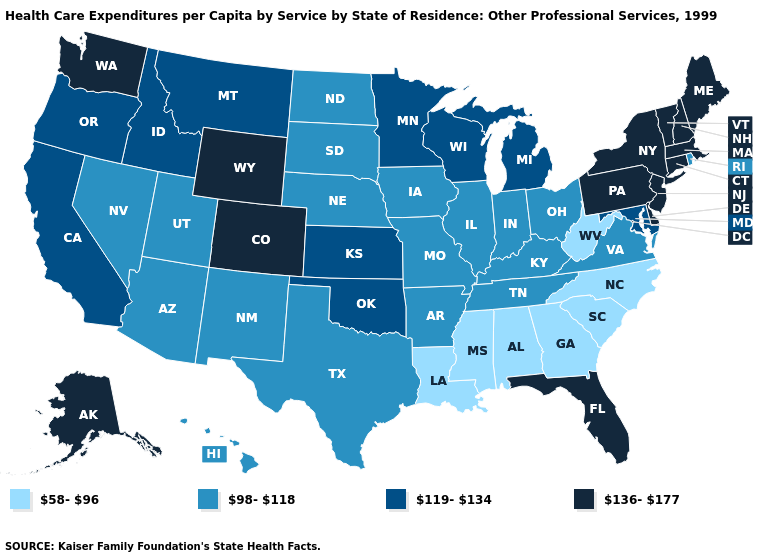Among the states that border Nevada , does Utah have the lowest value?
Short answer required. Yes. Does the map have missing data?
Give a very brief answer. No. Among the states that border Mississippi , does Arkansas have the highest value?
Write a very short answer. Yes. Does the map have missing data?
Be succinct. No. Does Indiana have a higher value than Georgia?
Be succinct. Yes. Among the states that border Delaware , which have the highest value?
Keep it brief. New Jersey, Pennsylvania. Does Wyoming have the highest value in the West?
Quick response, please. Yes. Does the map have missing data?
Write a very short answer. No. Name the states that have a value in the range 136-177?
Be succinct. Alaska, Colorado, Connecticut, Delaware, Florida, Maine, Massachusetts, New Hampshire, New Jersey, New York, Pennsylvania, Vermont, Washington, Wyoming. Does Hawaii have a higher value than Alabama?
Write a very short answer. Yes. What is the value of Virginia?
Be succinct. 98-118. Which states have the lowest value in the South?
Give a very brief answer. Alabama, Georgia, Louisiana, Mississippi, North Carolina, South Carolina, West Virginia. Does Georgia have the lowest value in the USA?
Give a very brief answer. Yes. Does Nebraska have the highest value in the MidWest?
Quick response, please. No. 